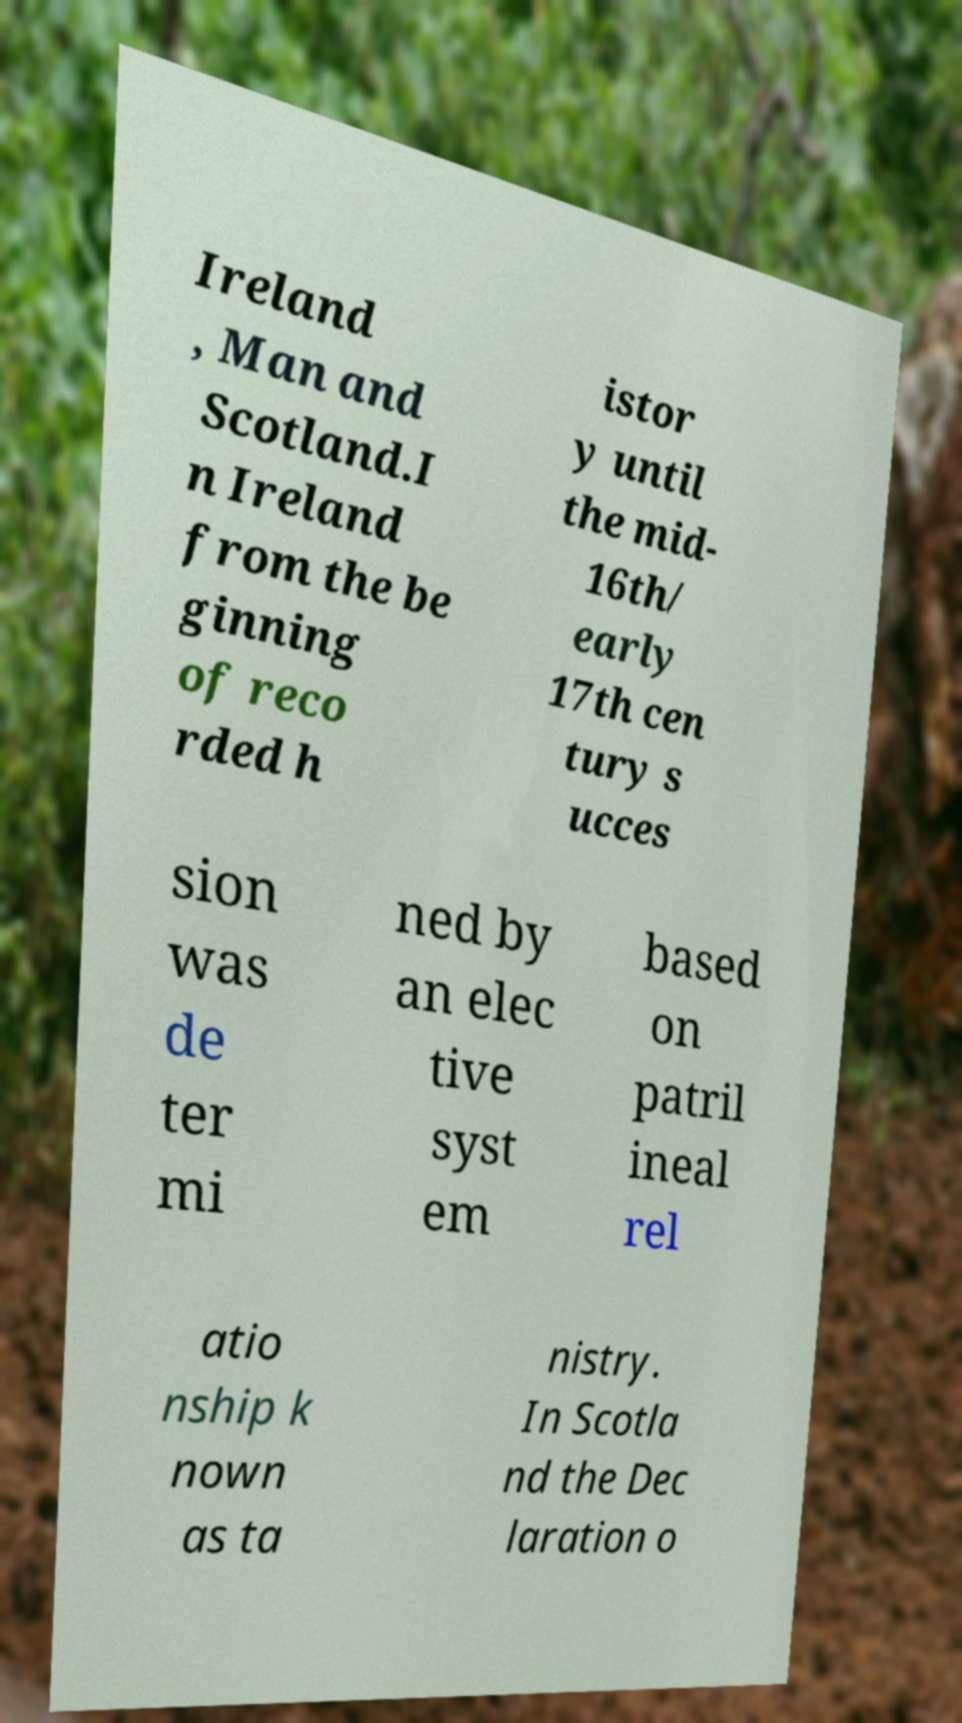What messages or text are displayed in this image? I need them in a readable, typed format. Ireland , Man and Scotland.I n Ireland from the be ginning of reco rded h istor y until the mid- 16th/ early 17th cen tury s ucces sion was de ter mi ned by an elec tive syst em based on patril ineal rel atio nship k nown as ta nistry. In Scotla nd the Dec laration o 